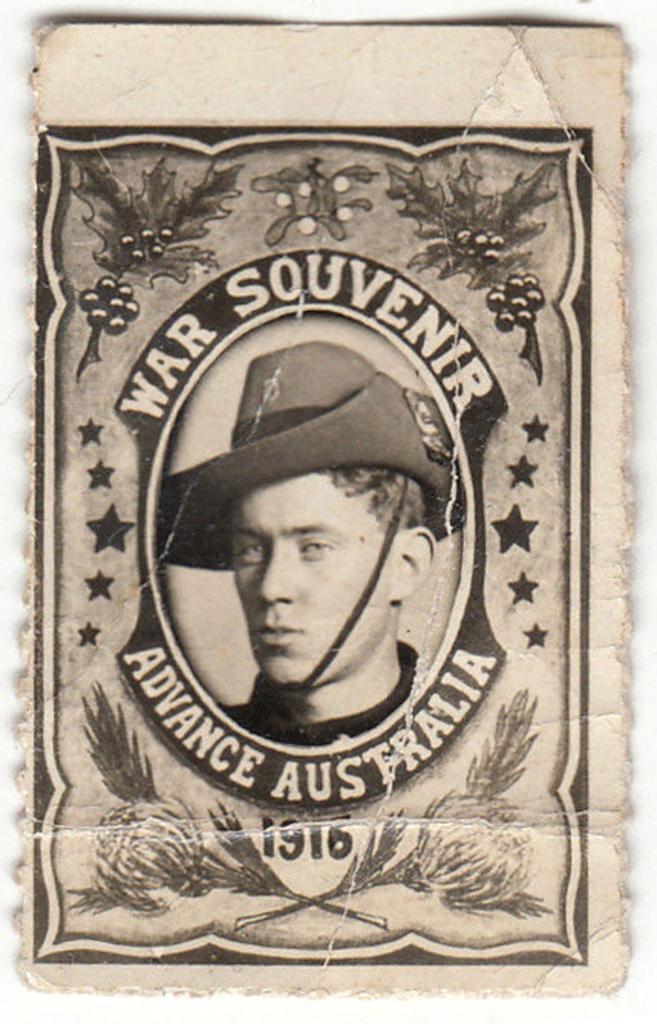How would you summarize this image in a sentence or two? In this image there is a piece of paper. On the paper there is a face of a man. The man is wearing a hat. Around the picture there is text. There are pictures of leaves, fruits, stars and grass on the paper. Around the paper there is a border. 